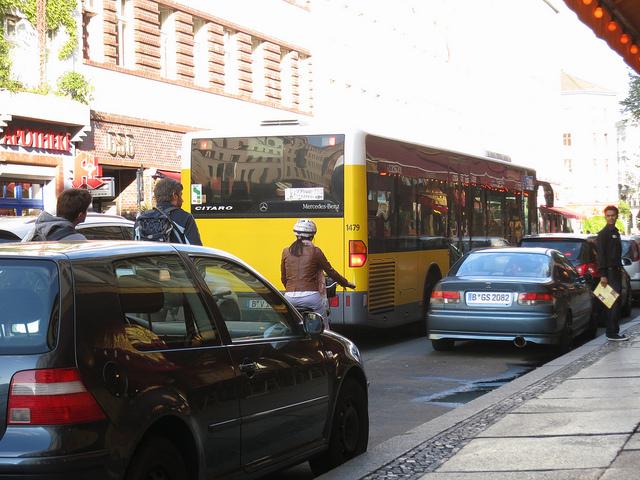Can you tell me more about the architecture in the image? Certainly! The buildings lining the street have a classic European architectural style, with traditional facades that include detailed window frames and what appears to be timber framing on the upper parts of the structure on the left. This suggests that the image may have been taken in a historic part of a European city where such architectural styling is preserved. 